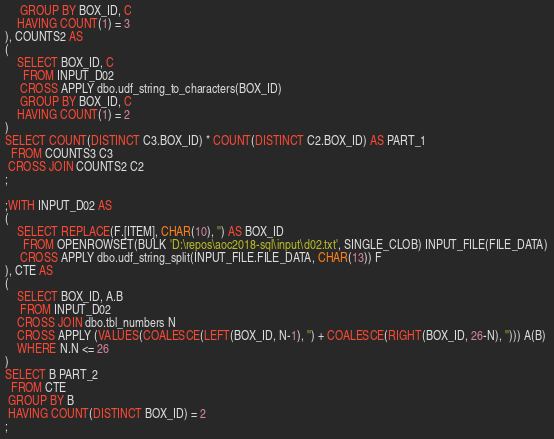Convert code to text. <code><loc_0><loc_0><loc_500><loc_500><_SQL_>     GROUP BY BOX_ID, C
    HAVING COUNT(1) = 3
), COUNTS2 AS
(
    SELECT BOX_ID, C
      FROM INPUT_D02
     CROSS APPLY dbo.udf_string_to_characters(BOX_ID) 
     GROUP BY BOX_ID, C
    HAVING COUNT(1) = 2
)
SELECT COUNT(DISTINCT C3.BOX_ID) * COUNT(DISTINCT C2.BOX_ID) AS PART_1
  FROM COUNTS3 C3
 CROSS JOIN COUNTS2 C2
;

;WITH INPUT_D02 AS 
(
    SELECT REPLACE(F.[ITEM], CHAR(10), '') AS BOX_ID 
      FROM OPENROWSET(BULK 'D:\repos\aoc2018-sql\input\d02.txt', SINGLE_CLOB) INPUT_FILE(FILE_DATA)
     CROSS APPLY dbo.udf_string_split(INPUT_FILE.FILE_DATA, CHAR(13)) F
), CTE AS
(
    SELECT BOX_ID, A.B
     FROM INPUT_D02
    CROSS JOIN dbo.tbl_numbers N
    CROSS APPLY (VALUES(COALESCE(LEFT(BOX_ID, N-1), '') + COALESCE(RIGHT(BOX_ID, 26-N), ''))) A(B) 
    WHERE N.N <= 26
)
SELECT B PART_2 
  FROM CTE
 GROUP BY B
 HAVING COUNT(DISTINCT BOX_ID) = 2
;
</code> 